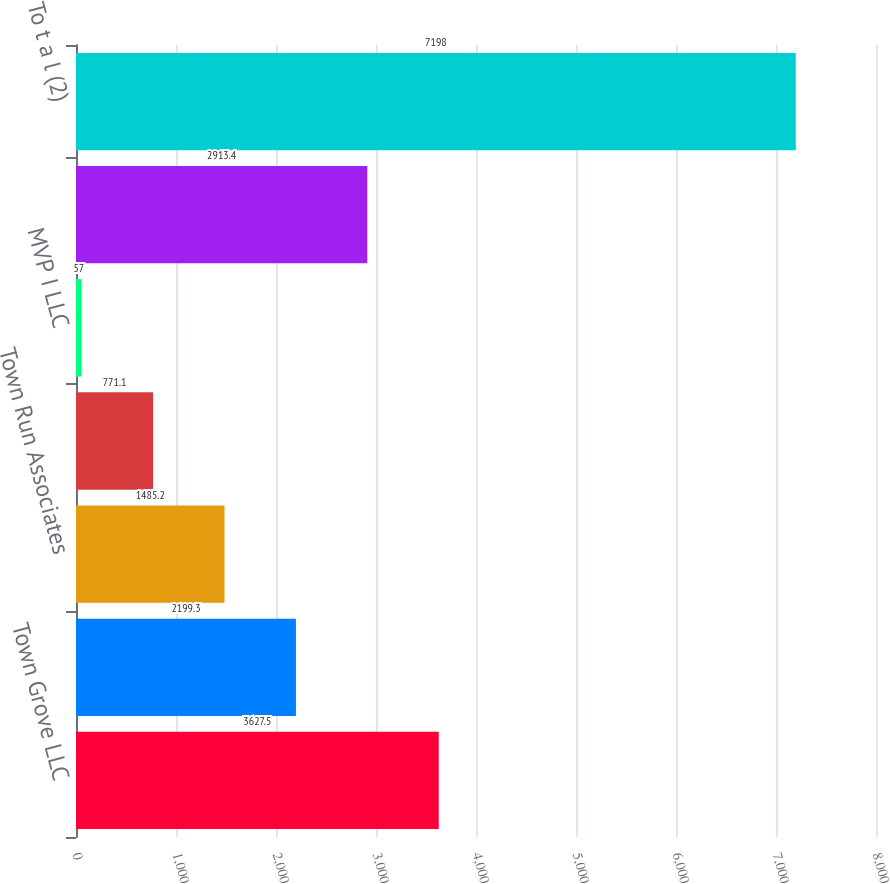Convert chart. <chart><loc_0><loc_0><loc_500><loc_500><bar_chart><fcel>Town Grove LLC<fcel>CVP I LLC<fcel>Town Run Associates<fcel>Avalon Terrace LLC^(1)<fcel>MVP I LLC<fcel>AvalonBay Value Added Fund LP<fcel>To t a l (2)<nl><fcel>3627.5<fcel>2199.3<fcel>1485.2<fcel>771.1<fcel>57<fcel>2913.4<fcel>7198<nl></chart> 